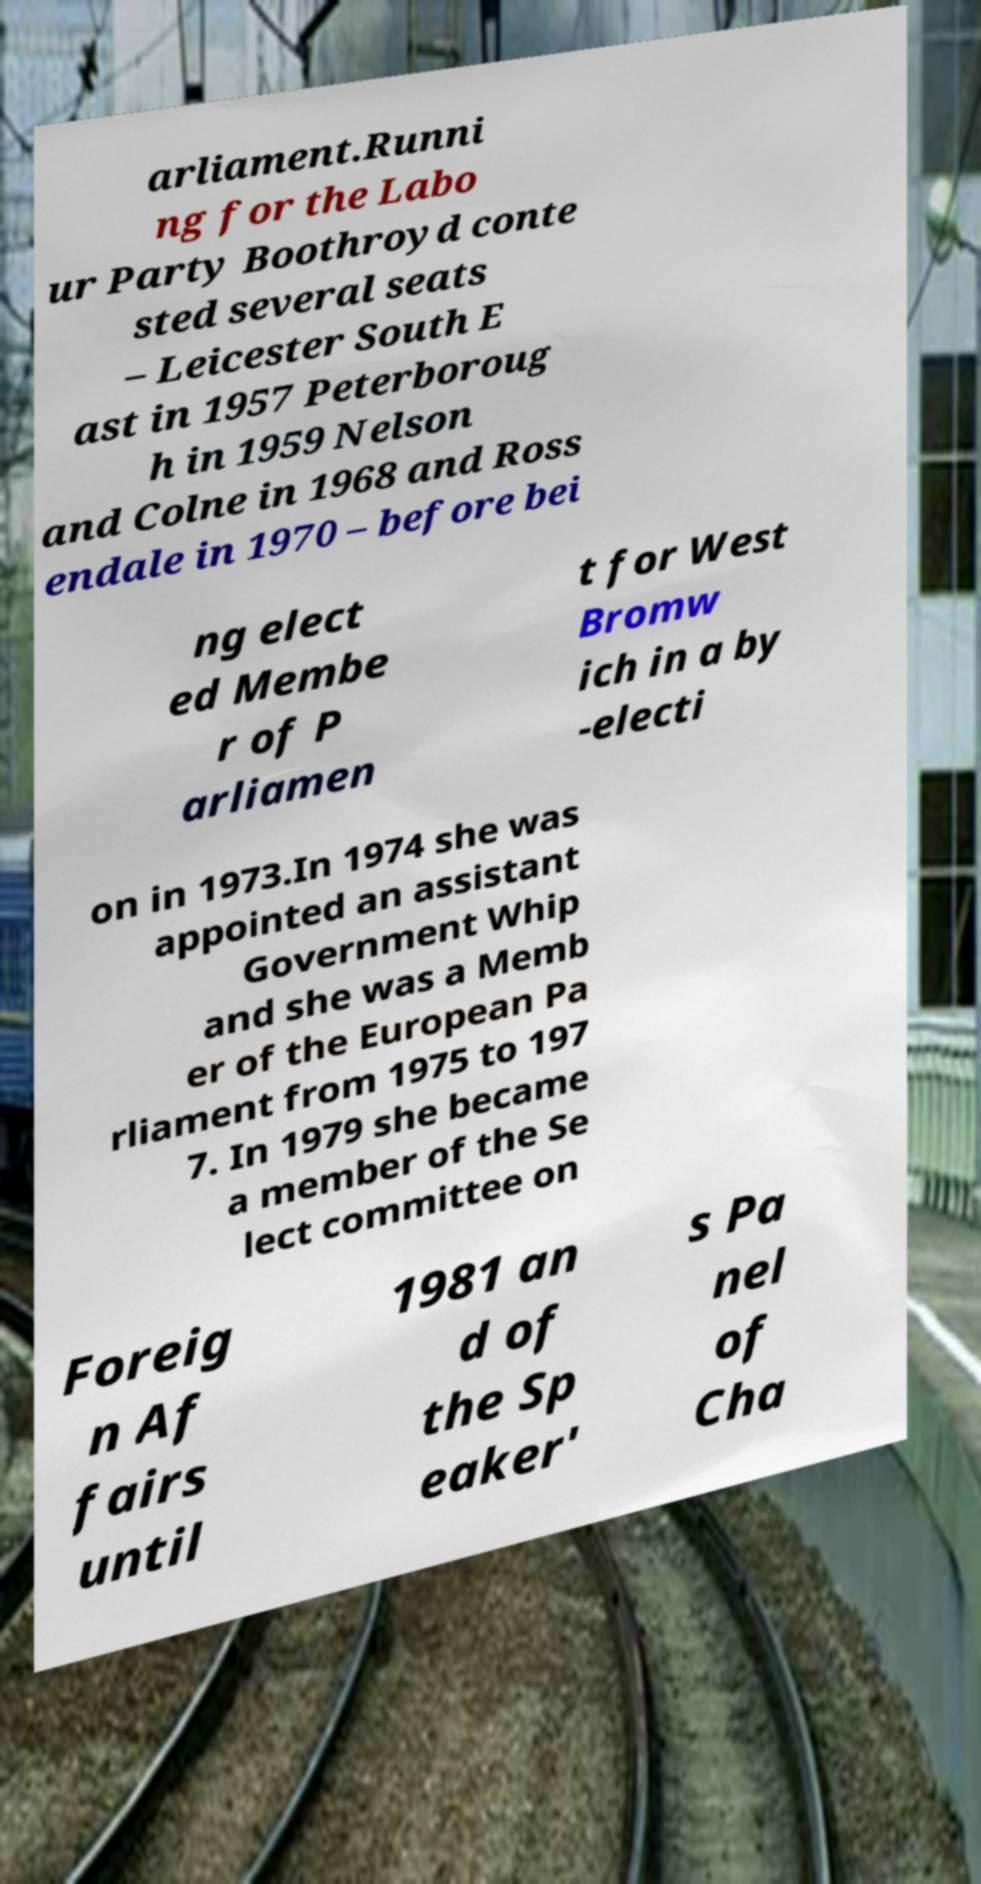Please identify and transcribe the text found in this image. arliament.Runni ng for the Labo ur Party Boothroyd conte sted several seats – Leicester South E ast in 1957 Peterboroug h in 1959 Nelson and Colne in 1968 and Ross endale in 1970 – before bei ng elect ed Membe r of P arliamen t for West Bromw ich in a by -electi on in 1973.In 1974 she was appointed an assistant Government Whip and she was a Memb er of the European Pa rliament from 1975 to 197 7. In 1979 she became a member of the Se lect committee on Foreig n Af fairs until 1981 an d of the Sp eaker' s Pa nel of Cha 